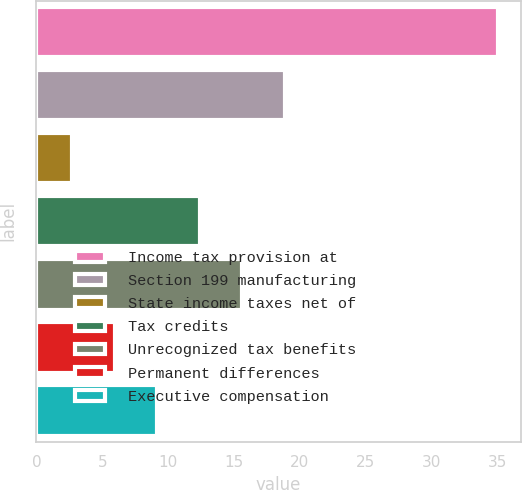Convert chart. <chart><loc_0><loc_0><loc_500><loc_500><bar_chart><fcel>Income tax provision at<fcel>Section 199 manufacturing<fcel>State income taxes net of<fcel>Tax credits<fcel>Unrecognized tax benefits<fcel>Permanent differences<fcel>Executive compensation<nl><fcel>35<fcel>18.85<fcel>2.7<fcel>12.39<fcel>15.62<fcel>5.93<fcel>9.16<nl></chart> 